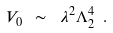<formula> <loc_0><loc_0><loc_500><loc_500>V _ { 0 } \ \sim \ \lambda ^ { 2 } \Lambda _ { 2 } ^ { 4 } \ . \</formula> 